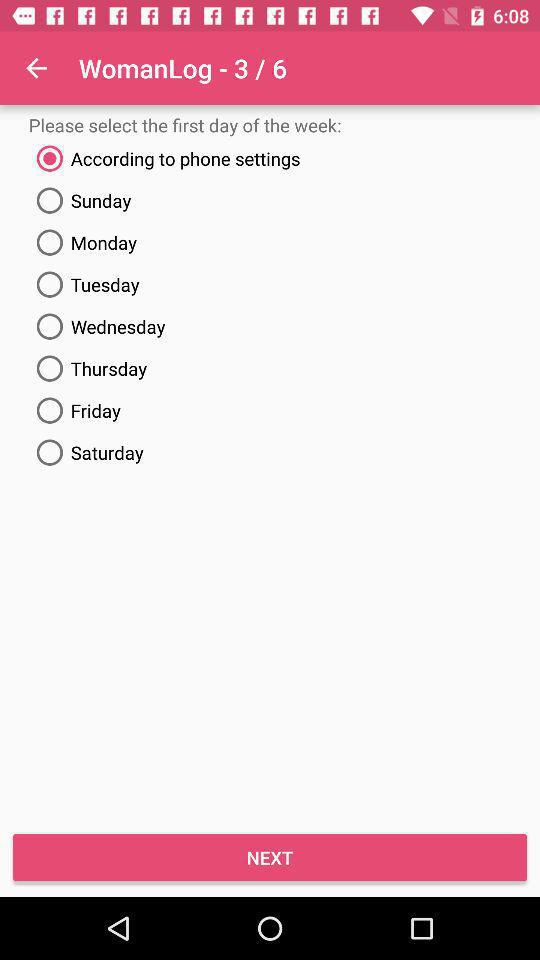Which "WomanLog" step is the person on? The person is on the third step. 